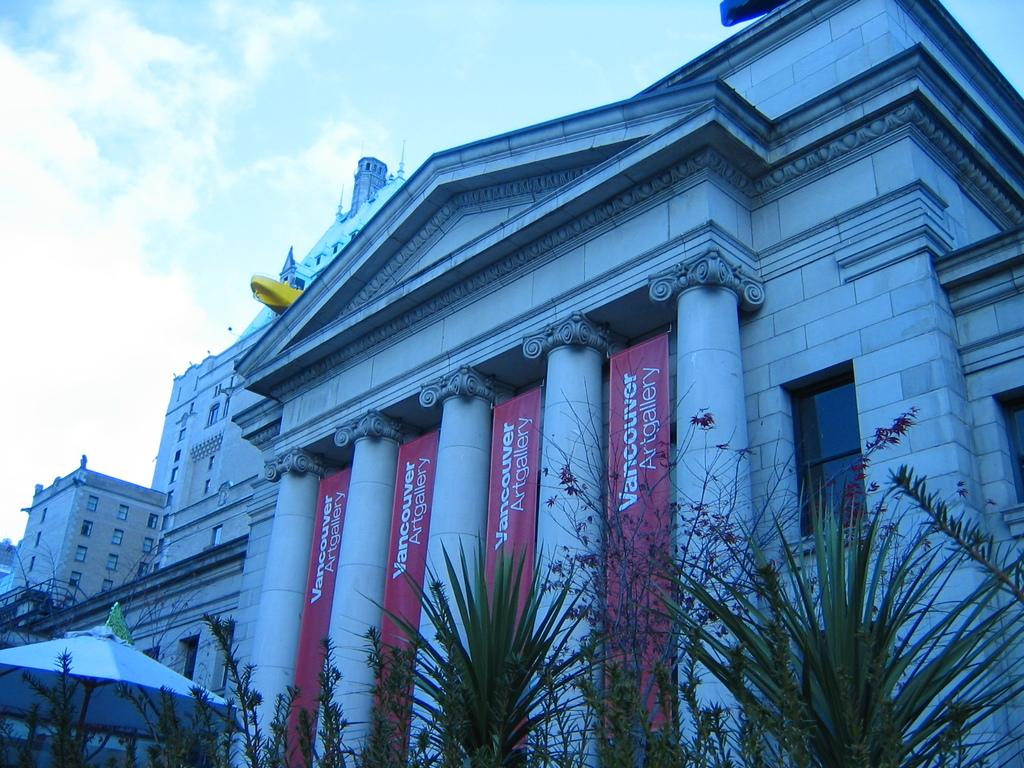What type of structures can be seen in the image? There are buildings in the image. What architectural elements are present in the image? There are pillars in the image. What decorative elements are present in the image? There are banners in the image. What type of vegetation is visible in the image? There are plants in the image. What symbolic element is present in the image? There is a flag in the image. What object is present for providing shade? There is an umbrella in the image. What can be seen in the background of the image? The sky is visible in the background of the image. What weather condition can be inferred from the sky? There are clouds in the sky, suggesting a partly cloudy day. Can you tell me how many times the lawyer cries in the image? There is no lawyer or crying depicted in the image. What type of wax is used to create the banners in the image? The provided facts do not mention any wax being used in the image. 